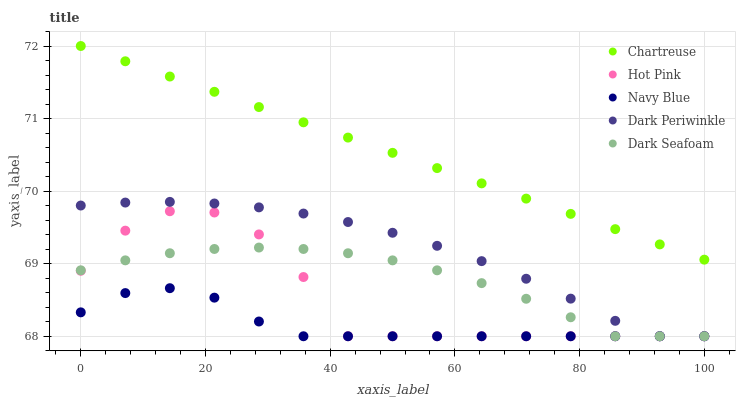Does Navy Blue have the minimum area under the curve?
Answer yes or no. Yes. Does Chartreuse have the maximum area under the curve?
Answer yes or no. Yes. Does Hot Pink have the minimum area under the curve?
Answer yes or no. No. Does Hot Pink have the maximum area under the curve?
Answer yes or no. No. Is Chartreuse the smoothest?
Answer yes or no. Yes. Is Hot Pink the roughest?
Answer yes or no. Yes. Is Hot Pink the smoothest?
Answer yes or no. No. Is Chartreuse the roughest?
Answer yes or no. No. Does Navy Blue have the lowest value?
Answer yes or no. Yes. Does Chartreuse have the lowest value?
Answer yes or no. No. Does Chartreuse have the highest value?
Answer yes or no. Yes. Does Hot Pink have the highest value?
Answer yes or no. No. Is Dark Periwinkle less than Chartreuse?
Answer yes or no. Yes. Is Chartreuse greater than Dark Seafoam?
Answer yes or no. Yes. Does Dark Periwinkle intersect Navy Blue?
Answer yes or no. Yes. Is Dark Periwinkle less than Navy Blue?
Answer yes or no. No. Is Dark Periwinkle greater than Navy Blue?
Answer yes or no. No. Does Dark Periwinkle intersect Chartreuse?
Answer yes or no. No. 